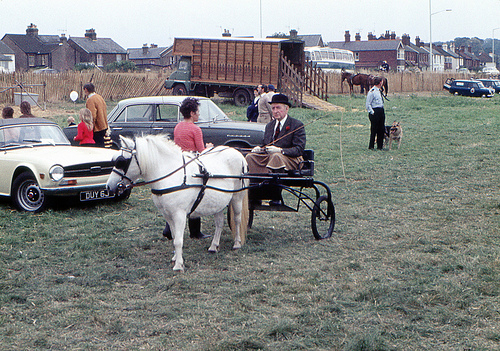How many people are sitting in a buggy? There is one person sitting in the buggy, which is being pulled by a single white horse. The person appears to be an older gentleman wearing a dark hat and a coat, holding the reins and looking forward. 